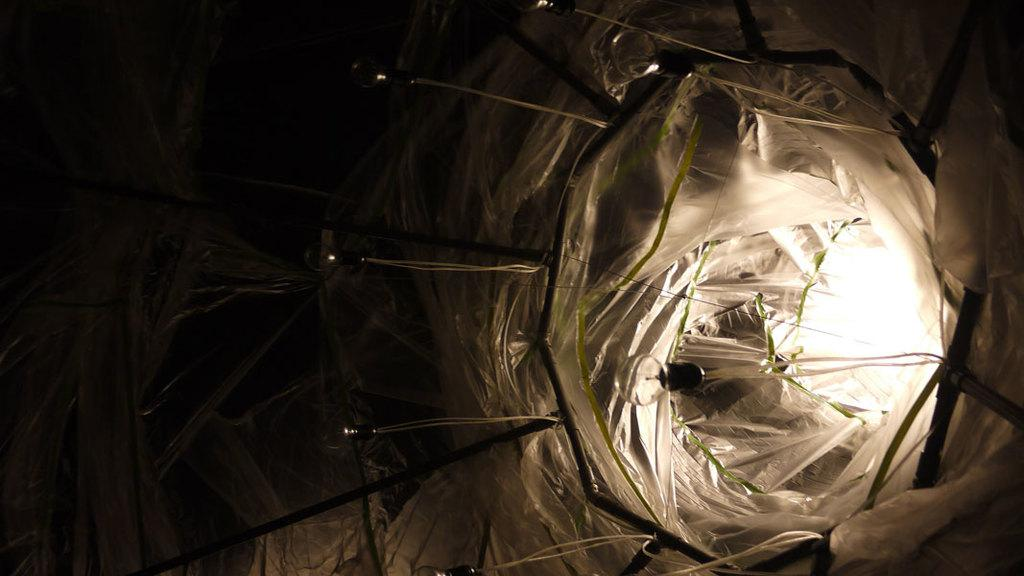What type of lighting is present in the image? There are decorative lights in the image. What are the small rods used for in the image? The small rods are used for holding the decorative lights, and there is a cover on them in the image. What is the source of light in the image? There is a bulb in the image. Can you describe the effect of the lighting in the image? There is light visible in the image. What type of produce is being sold by the passenger in the image? There is no produce or passenger present in the image; it features decorative lights with small rods, a cover, and a bulb. What topic are the people talking about in the image? There are no people or conversation present in the image; it only shows decorative lights with small rods, a cover, and a bulb. 